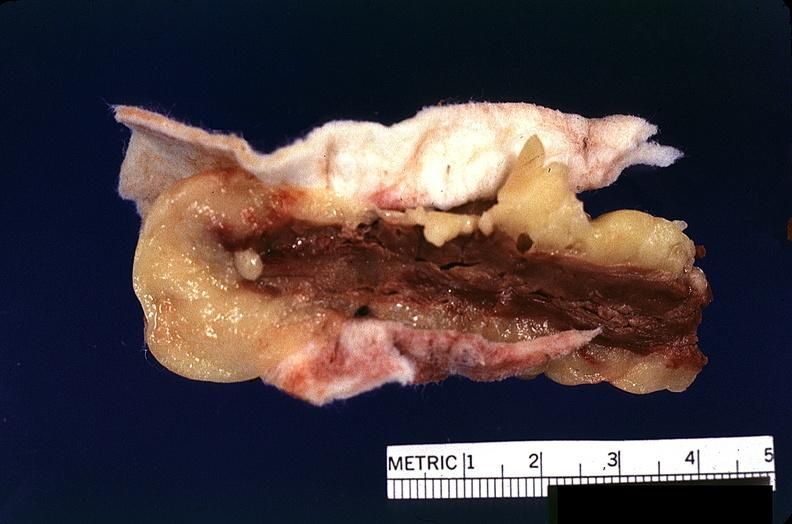s cardiovascular present?
Answer the question using a single word or phrase. Yes 